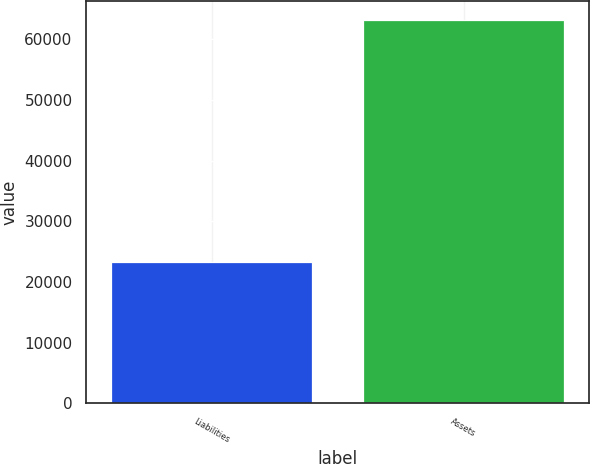Convert chart. <chart><loc_0><loc_0><loc_500><loc_500><bar_chart><fcel>Liabilities<fcel>Assets<nl><fcel>23307<fcel>63201<nl></chart> 